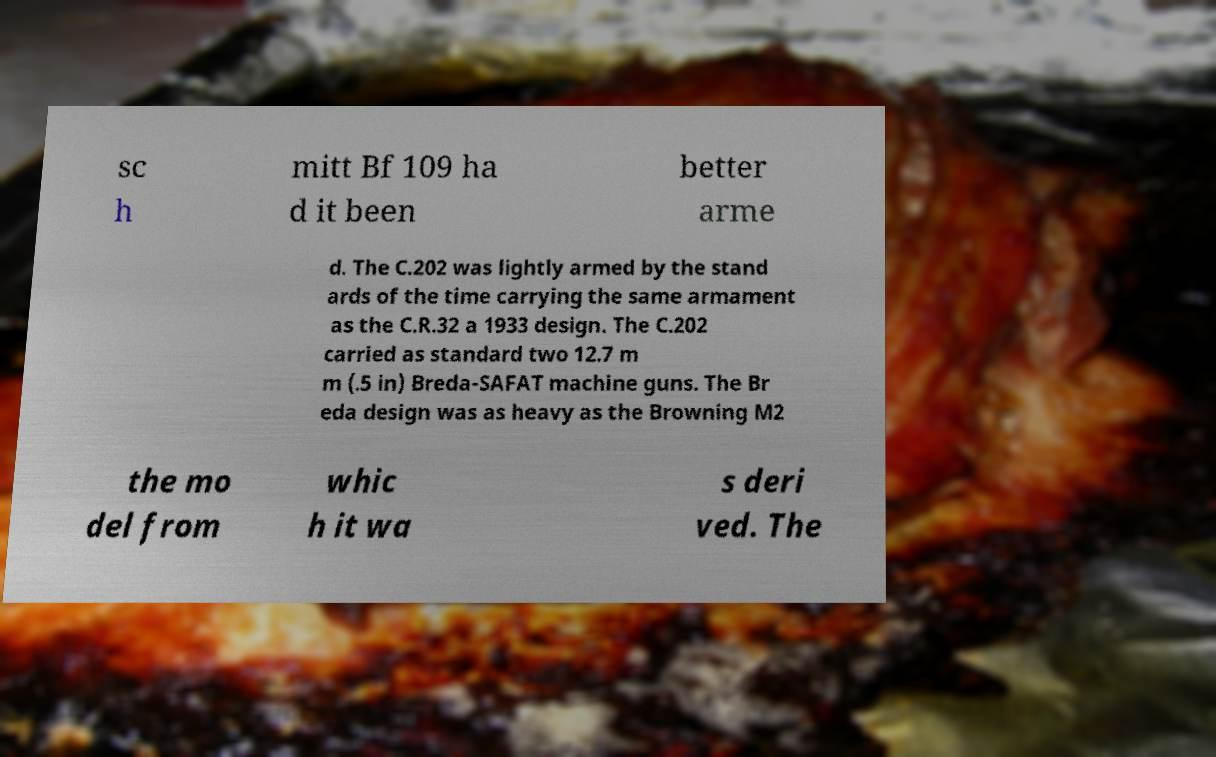Can you read and provide the text displayed in the image?This photo seems to have some interesting text. Can you extract and type it out for me? sc h mitt Bf 109 ha d it been better arme d. The C.202 was lightly armed by the stand ards of the time carrying the same armament as the C.R.32 a 1933 design. The C.202 carried as standard two 12.7 m m (.5 in) Breda-SAFAT machine guns. The Br eda design was as heavy as the Browning M2 the mo del from whic h it wa s deri ved. The 